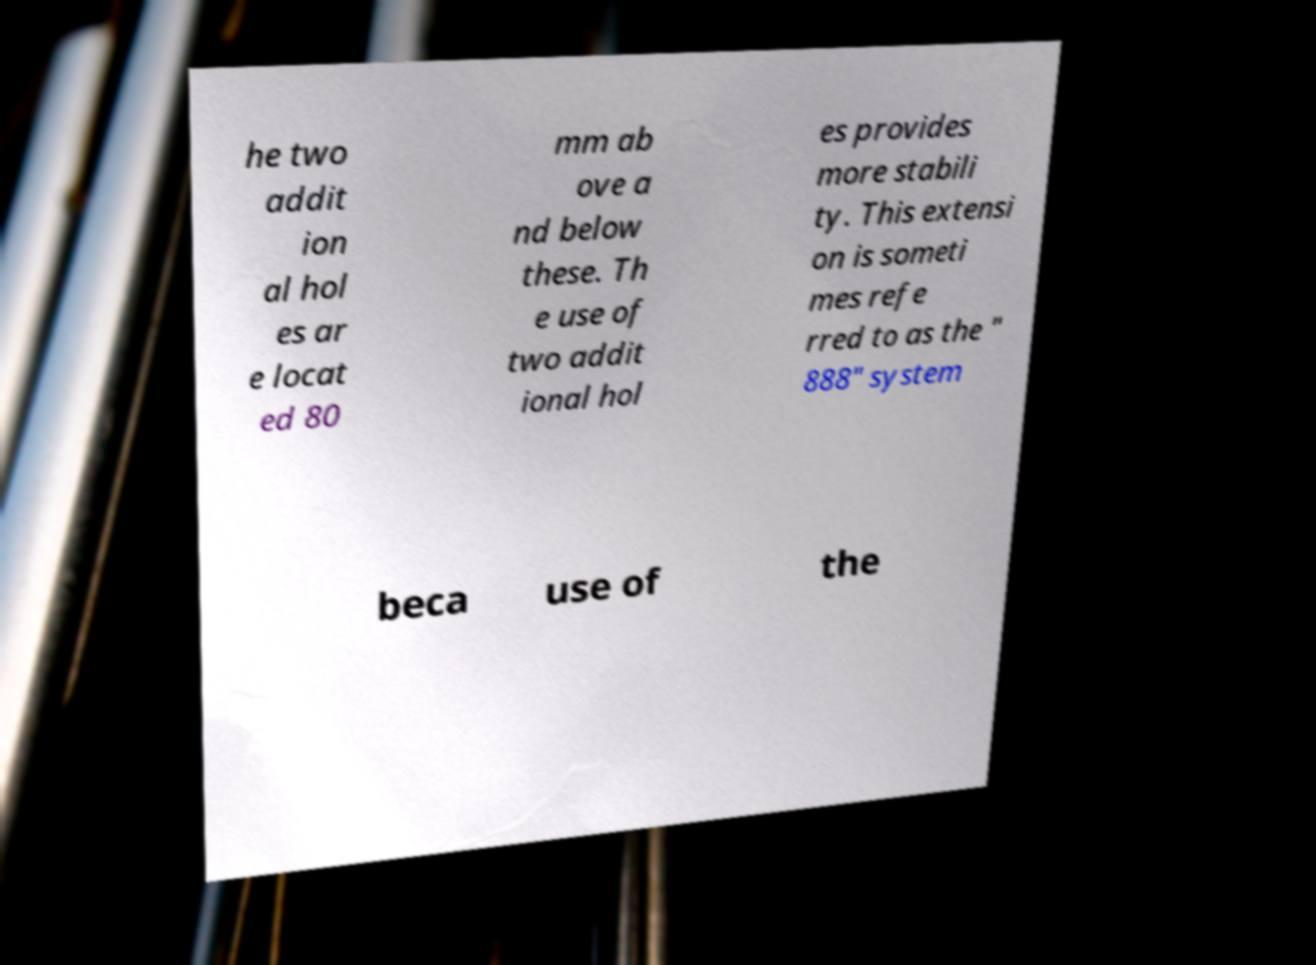Could you assist in decoding the text presented in this image and type it out clearly? he two addit ion al hol es ar e locat ed 80 mm ab ove a nd below these. Th e use of two addit ional hol es provides more stabili ty. This extensi on is someti mes refe rred to as the " 888" system beca use of the 